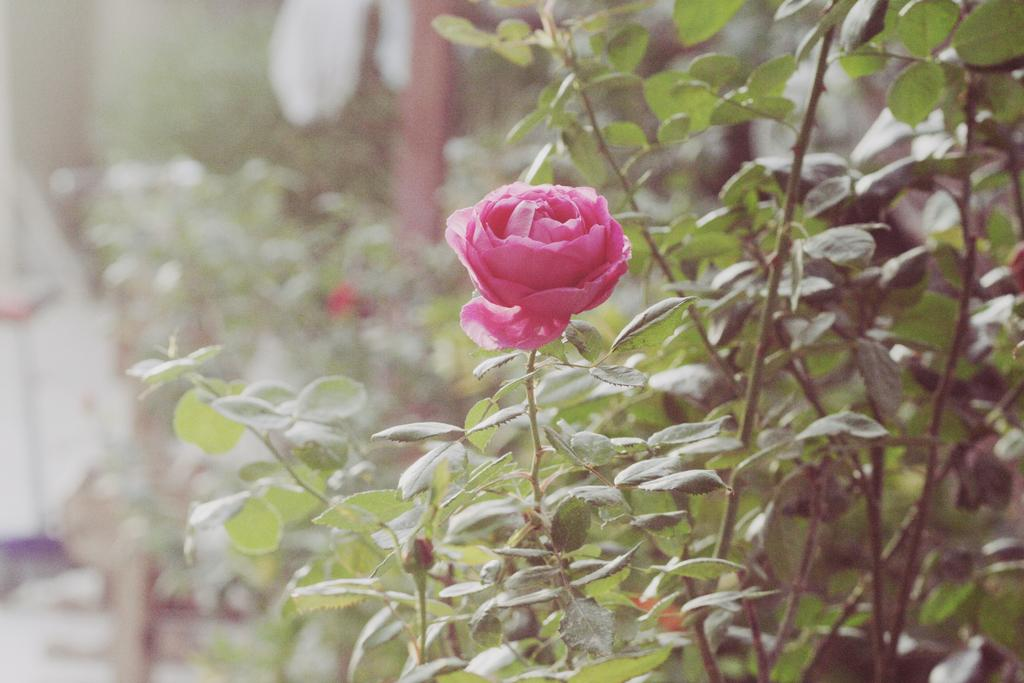What type of flower is in the image? There is a pink rose flower in the image. Where is the pink rose flower located? The pink rose flower is on a plant. What can be seen in the background of the image? There are many plants visible in the background of the image. What decision does the toad make in the image? There is no toad present in the image, so no decision can be made by a toad. 